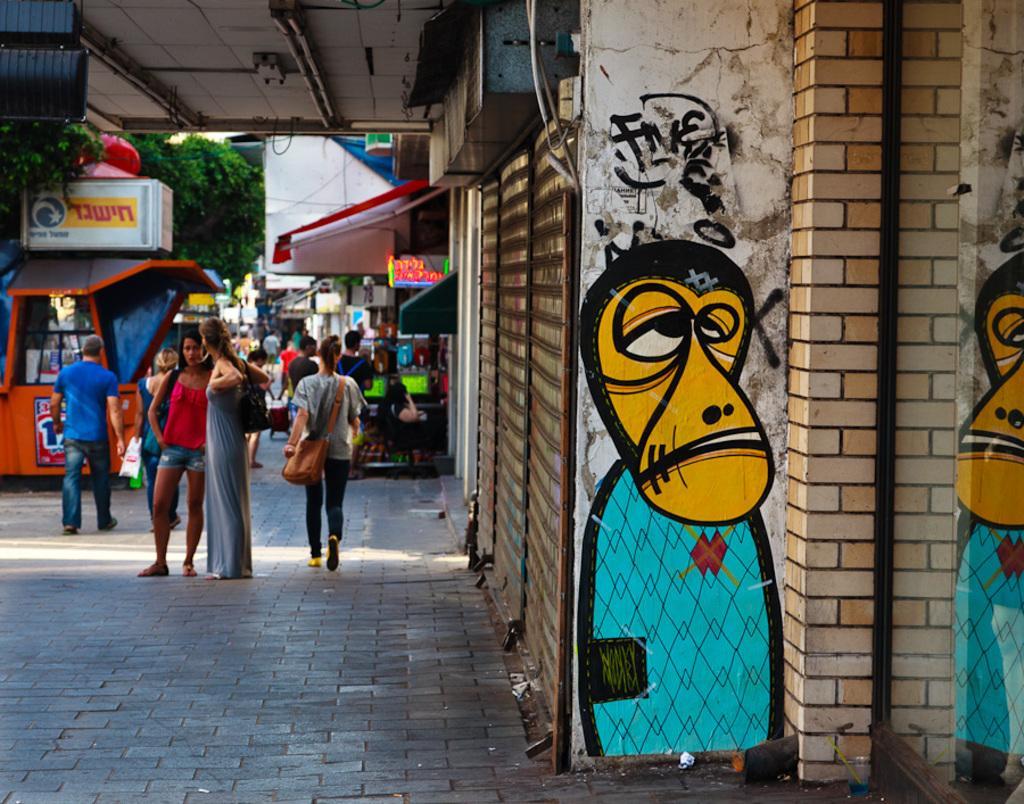Can you describe this image briefly? In this image on the left side there are a group of people, and also there are some stores trees. On the right side there is a wall, shutters. On the wall there is some art, at the top there is ceiling and some pipes 